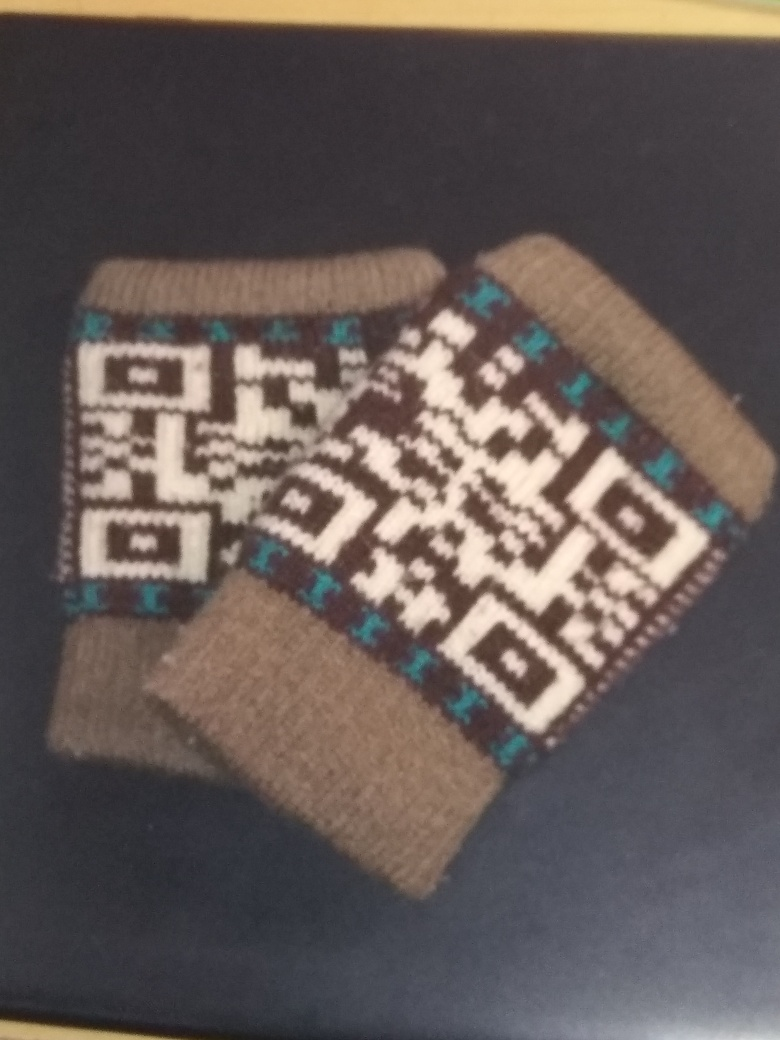What might be the significance of the pattern on these socks? Such patterns are often indicative of cultural heritage, representing a region's or community's traditional designs that may carry specific meanings or stories passed down through generations. 